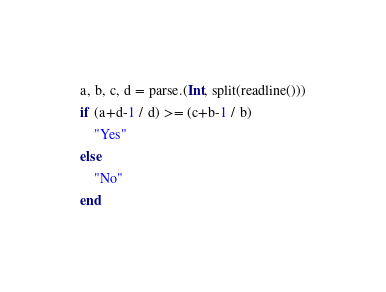<code> <loc_0><loc_0><loc_500><loc_500><_Julia_>a, b, c, d = parse.(Int, split(readline()))
if (a+d-1 / d) >= (c+b-1 / b)
    "Yes"
else
    "No"
end
</code> 